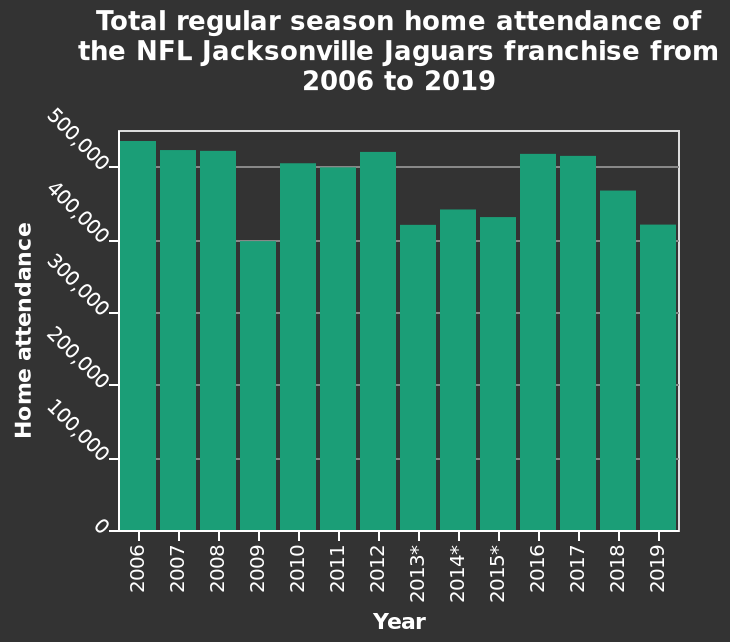<image>
please enumerates aspects of the construction of the chart Total regular season home attendance of the NFL Jacksonville Jaguars franchise from 2006 to 2019 is a bar diagram. The x-axis plots Year with linear scale of range 2006 to 2019 while the y-axis plots Home attendance along linear scale with a minimum of 0 and a maximum of 500,000. What is the maximum value on the y-axis? The maximum value on the y-axis is 500,000. What was the attendance of the NFL Jacksonville Jaguars in 2009?  The attendance of the NFL Jacksonville Jaguars in 2009 was 400,000. In which year did the NFL Jacksonville Jaguars have the lowest attendance?  The NFL Jacksonville Jaguars had the lowest attendance in 2009. What is the average attendance for the NFL Jacksonville Jaguars?  The average attendance for the NFL Jacksonville Jaguars is normally 500,000. 